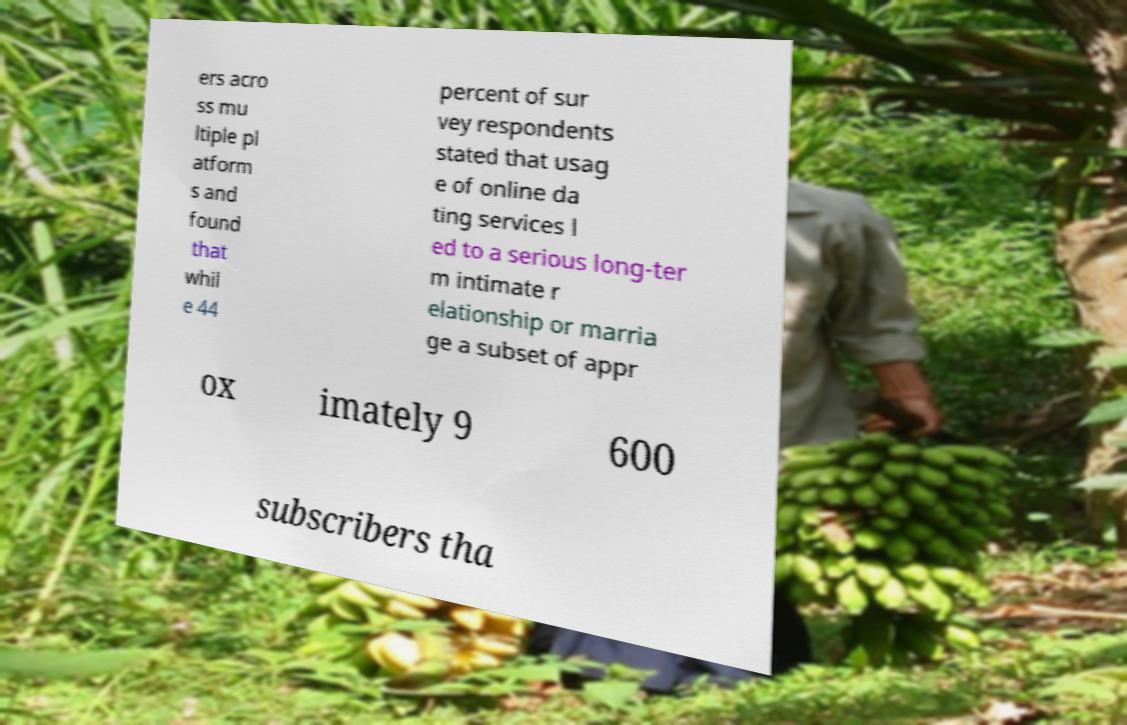Can you accurately transcribe the text from the provided image for me? ers acro ss mu ltiple pl atform s and found that whil e 44 percent of sur vey respondents stated that usag e of online da ting services l ed to a serious long-ter m intimate r elationship or marria ge a subset of appr ox imately 9 600 subscribers tha 